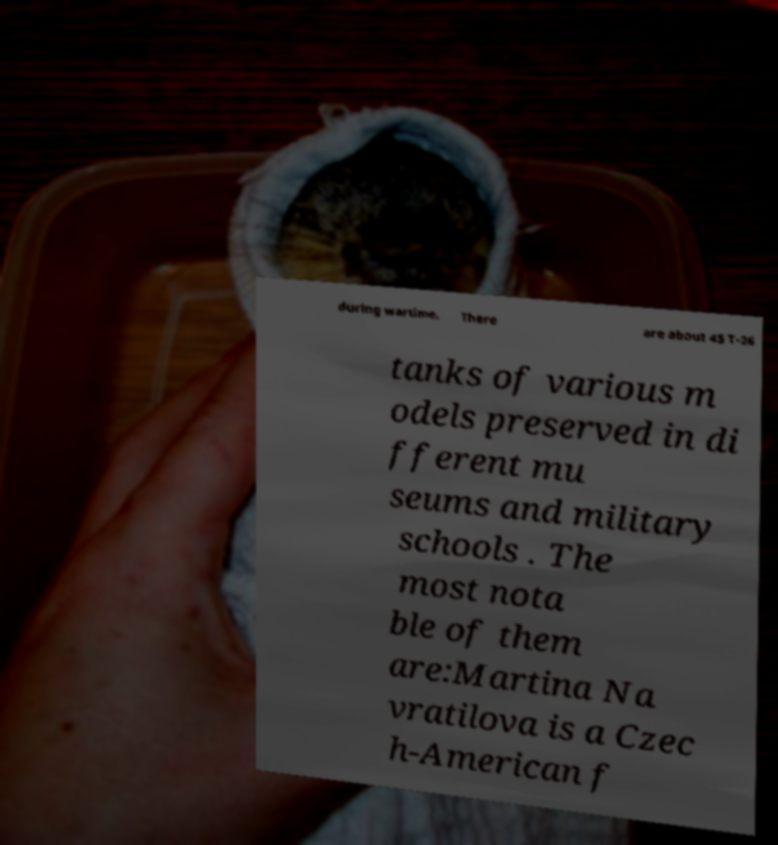There's text embedded in this image that I need extracted. Can you transcribe it verbatim? during wartime. There are about 45 T-26 tanks of various m odels preserved in di fferent mu seums and military schools . The most nota ble of them are:Martina Na vratilova is a Czec h-American f 